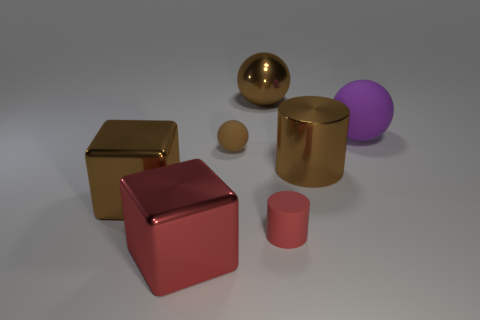Does the big purple object have the same shape as the brown rubber object? yes 